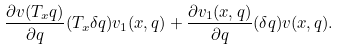Convert formula to latex. <formula><loc_0><loc_0><loc_500><loc_500>\frac { \partial v ( T _ { x } q ) } { \partial q } ( T _ { x } \delta q ) v _ { 1 } ( x , q ) + \frac { \partial v _ { 1 } ( x , q ) } { \partial q } ( \delta q ) v ( x , q ) .</formula> 